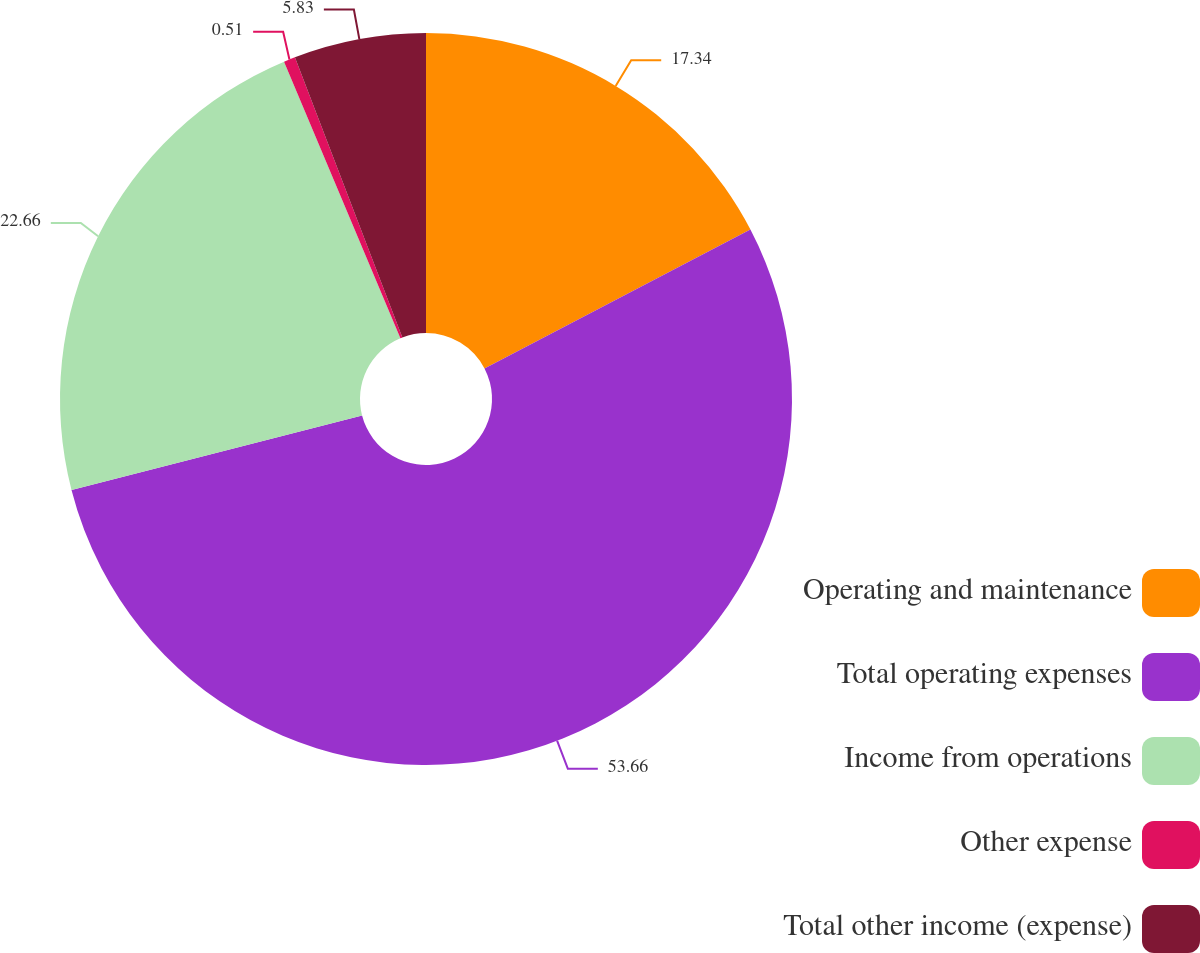<chart> <loc_0><loc_0><loc_500><loc_500><pie_chart><fcel>Operating and maintenance<fcel>Total operating expenses<fcel>Income from operations<fcel>Other expense<fcel>Total other income (expense)<nl><fcel>17.34%<fcel>53.66%<fcel>22.66%<fcel>0.51%<fcel>5.83%<nl></chart> 